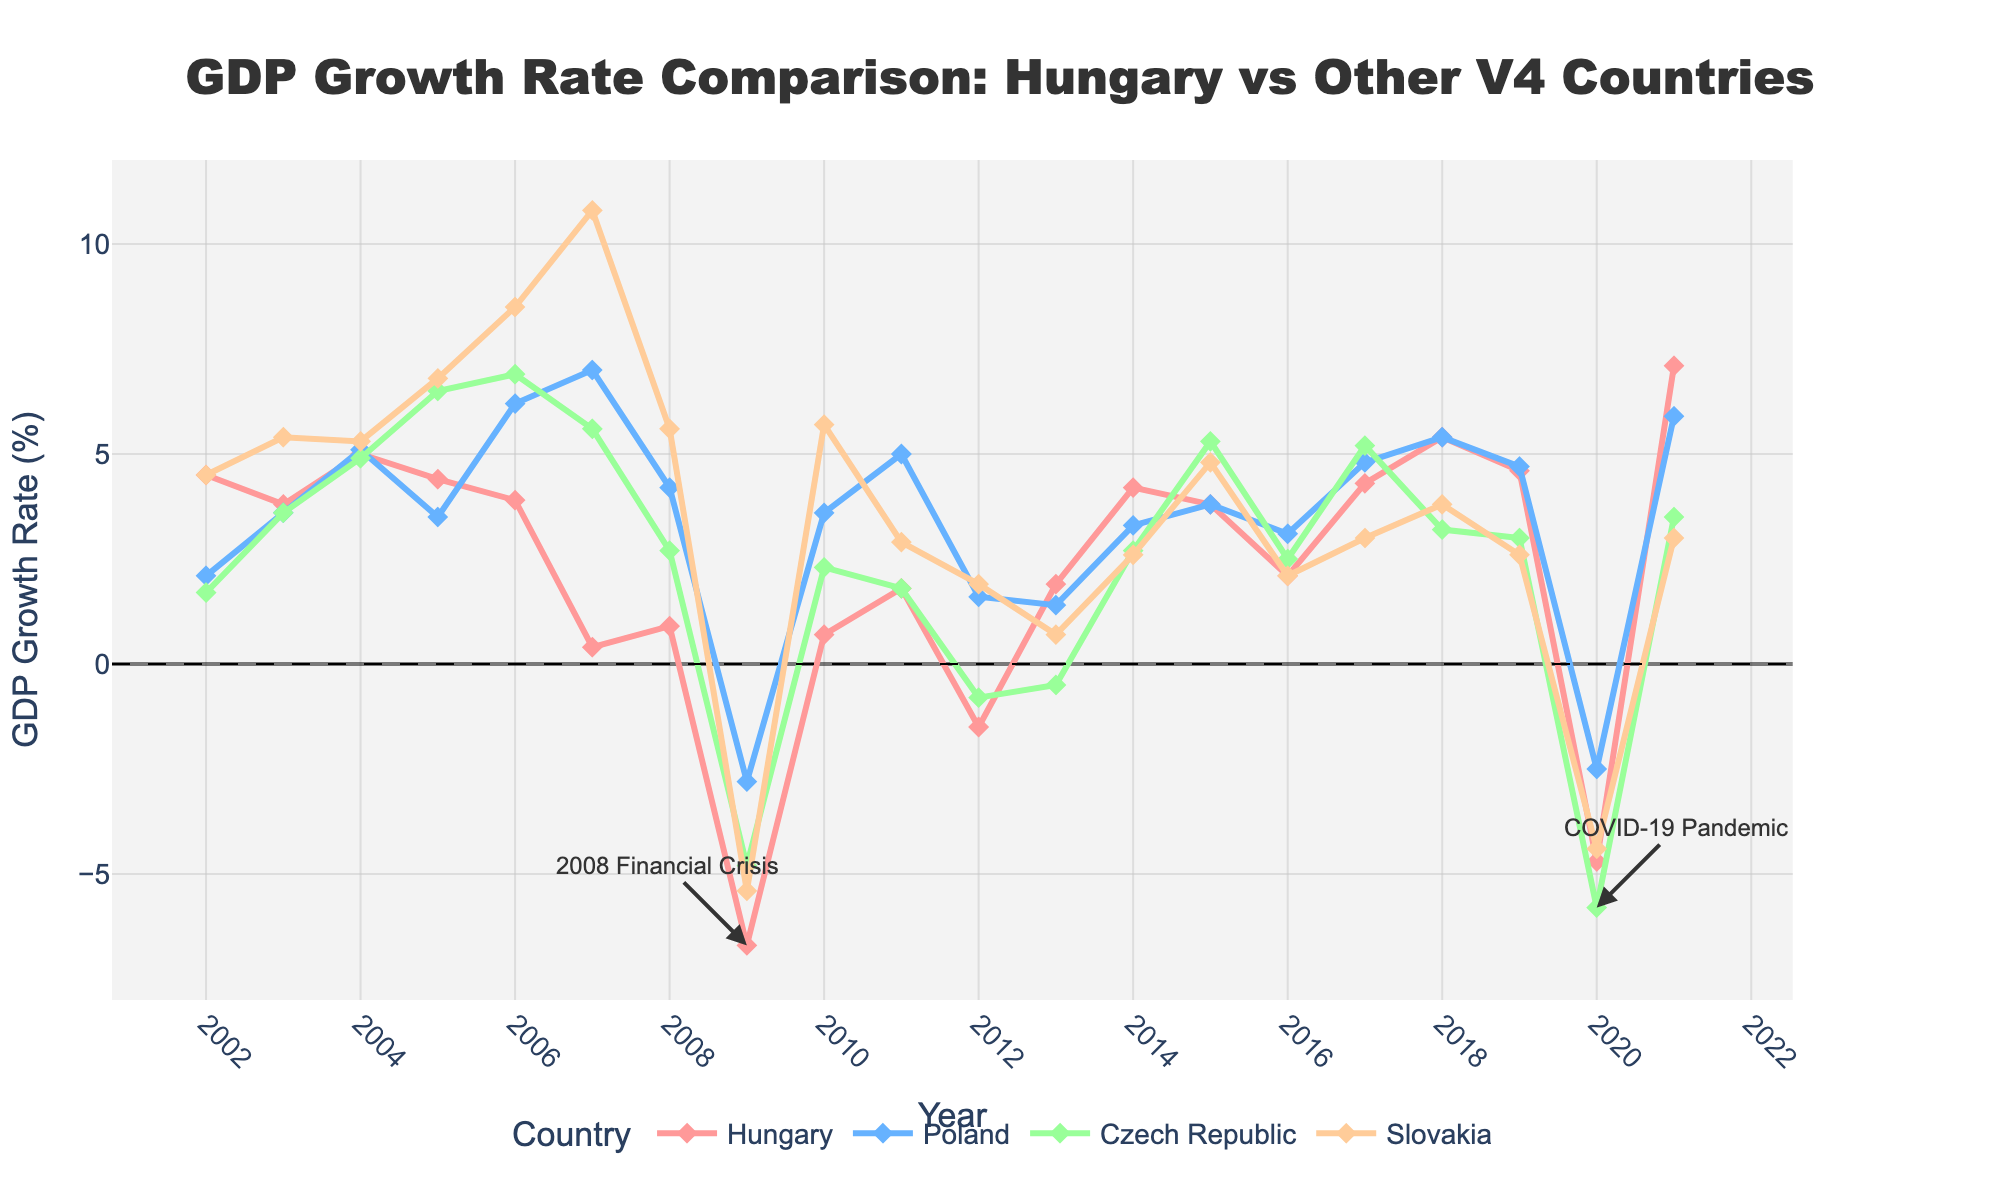What were the GDP growth rates for Hungary and Poland in 2007, and which country had a higher growth rate? Look at the values for Hungary and Poland in the year 2007 on the figure. Hungary shows a growth rate of 0.4%, and Poland shows 7.0%. Thus, Poland had a higher growth rate.
Answer: Poland What was the overall trend for Slovakia's GDP growth rate from 2002 to 2021? Observe the line representing Slovakia. It starts high, fluctuates significantly, showing peaks and declines (notably in 2006, 2009, 2020), before a recovery in 2021.
Answer: Fluctuating In which years did all four countries experience negative GDP growth rates? Examine the figure to find years where all four lines dip below the y-axis (0%). This occurs in 2009 and 2020.
Answer: 2009 and 2020 Which country had the most volatile GDP growth rate over the period? Assess the lines representing each country. Volatility indicates sharp rises and falls. Slovakia shows the most dramatic swings, especially with peaks in 2006, 2007, and dips in 2009 and 2020.
Answer: Slovakia During the 2008 Financial Crisis, which country had the smallest GDP decline in 2009? Locate 2009 and compare the GDP growth rates of all countries. Poland had the smallest decline at -2.8%.
Answer: Poland What is the difference in Hungary's GDP growth rate between the highest year and the lowest year? Identify the highest (2021, 7.1%) and lowest (2009, -6.7%) data points for Hungary. The difference is 7.1% - (-6.7%) = 7.1% + 6.7% = 13.8%.
Answer: 13.8% In which year did Hungary’s GDP growth rate first fall below zero after 2000, and what was it? Identify Hungary’s growth rate falling below zero after 2000. This occurred in 2012, with a growth rate of -1.5%.
Answer: 2012, -1.5% By how much did the GDP growth rates of Hungary and the Czech Republic differ in 2019? In 2019, Hungary had a growth rate of 4.6%, and the Czech Republic had 3.0%. The difference is 4.6% - 3.0% = 1.6%.
Answer: 1.6% Which country had the highest GDP growth rate during the COVID-19 pandemic in 2020 and what was it? Look at the 2020 GDP growth rates for all countries. Slovakia had the smallest decline, hence the highest among the negative rates at -4.4%.
Answer: Slovakia, -4.4% 